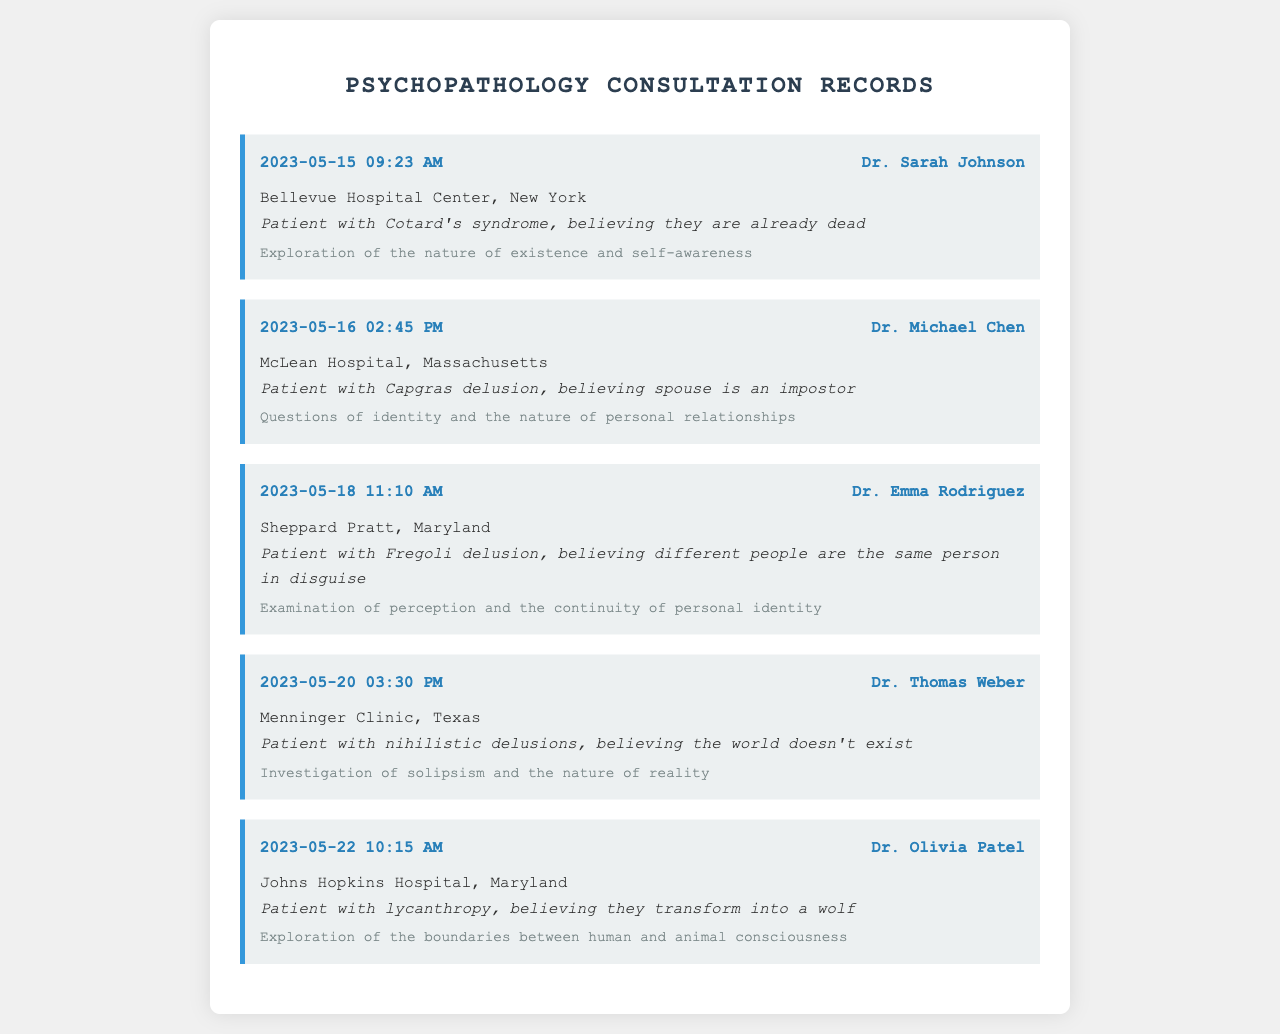What is the date of the first recorded call? The first recorded call is dated May 15, 2023.
Answer: May 15, 2023 Who is the psychiatrist associated with the delusion of Cotard's syndrome? The psychiatrist associated with the delusion of Cotard's syndrome is Dr. Sarah Johnson.
Answer: Dr. Sarah Johnson Which hospital is linked with the patient experiencing Capgras delusion? The hospital linked with the patient experiencing Capgras delusion is McLean Hospital, Massachusetts.
Answer: McLean Hospital, Massachusetts What is the ontological aspect discussed with respect to the patient with nihilistic delusions? The ontological aspect discussed is the investigation of solipsism and the nature of reality.
Answer: Investigation of solipsism and the nature of reality Who consulted about the case of a patient believing they transform into a wolf? The consultation about the patient believing they transform into a wolf was done by Dr. Olivia Patel.
Answer: Dr. Olivia Patel What type of delusion does the patient from Sheppard Pratt have? The patient from Sheppard Pratt has Fregoli delusion.
Answer: Fregoli delusion What time was the consultation regarding the lycanthropy case? The consultation regarding the lycanthropy case was at 10:15 AM.
Answer: 10:15 AM What is a key philosophical question related to the case of Capgras delusion? A key philosophical question is about the nature of personal relationships.
Answer: Nature of personal relationships 